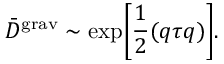<formula> <loc_0><loc_0><loc_500><loc_500>{ \bar { D } } ^ { g r a v } \sim \exp \left [ \frac { 1 } { 2 } ( q \tau q ) \right ] .</formula> 